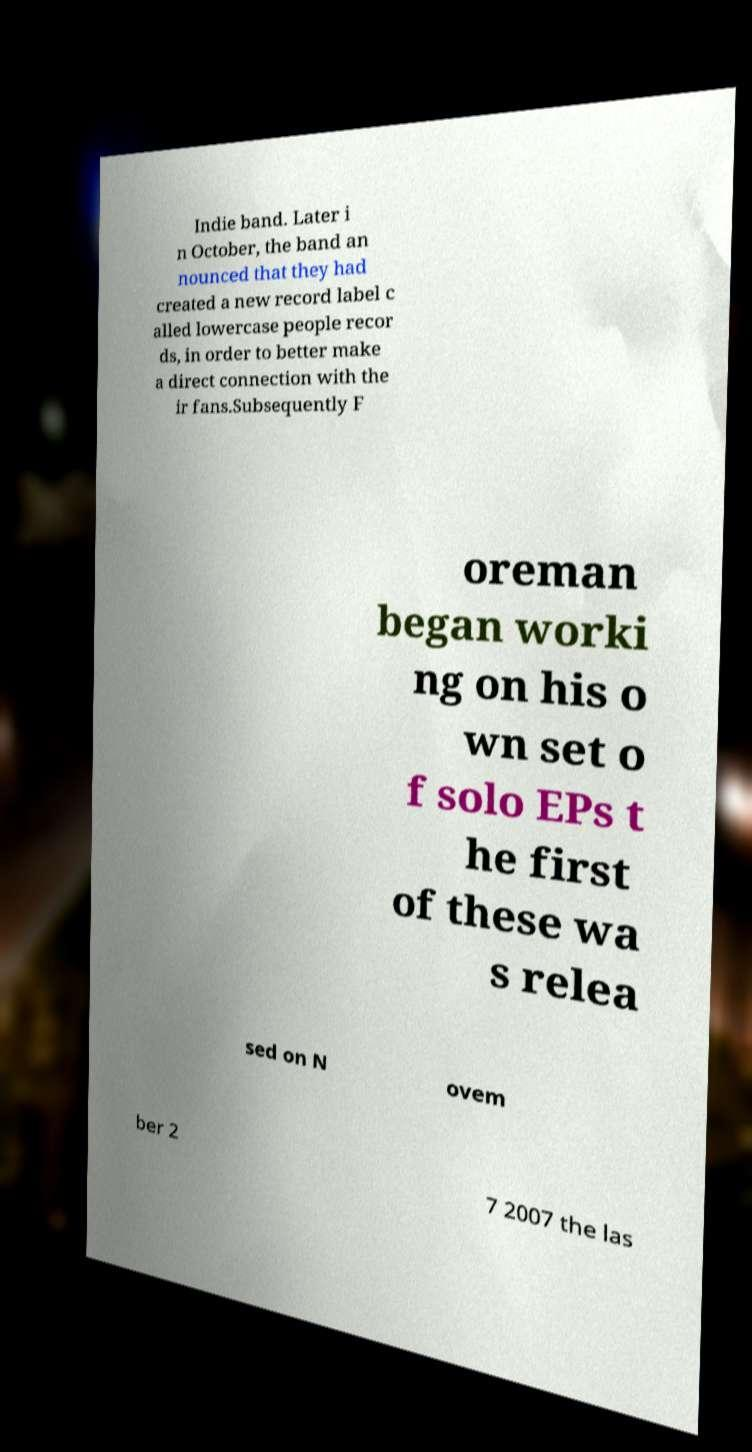Could you assist in decoding the text presented in this image and type it out clearly? Indie band. Later i n October, the band an nounced that they had created a new record label c alled lowercase people recor ds, in order to better make a direct connection with the ir fans.Subsequently F oreman began worki ng on his o wn set o f solo EPs t he first of these wa s relea sed on N ovem ber 2 7 2007 the las 